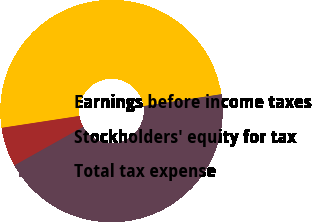Convert chart to OTSL. <chart><loc_0><loc_0><loc_500><loc_500><pie_chart><fcel>Earnings before income taxes<fcel>Stockholders' equity for tax<fcel>Total tax expense<nl><fcel>50.0%<fcel>5.71%<fcel>44.29%<nl></chart> 